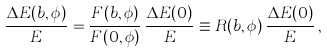Convert formula to latex. <formula><loc_0><loc_0><loc_500><loc_500>\frac { \Delta E ( { b } , \phi ) } { E } = \frac { F ( { b } , \phi ) } { F ( { 0 } , \phi ) } \, \frac { \Delta E ( 0 ) } { E } \equiv R ( { b } , \phi ) \, \frac { \Delta E ( 0 ) } { E } \, ,</formula> 